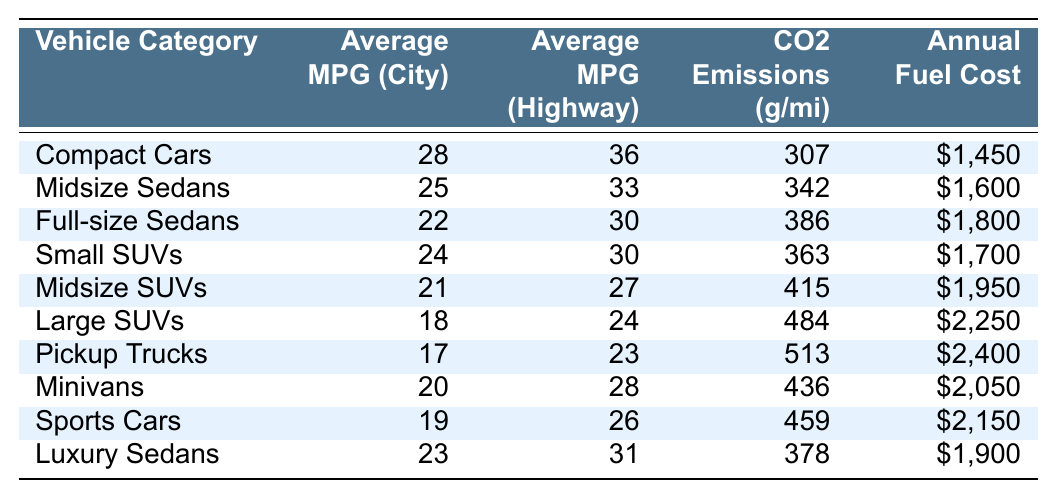What is the average MPG for Compact Cars in the city? From the table, the average MPG (City) for Compact Cars is directly listed as 28.
Answer: 28 What is the average highway MPG for Luxury Sedans? According to the table, the average MPG (Highway) for Luxury Sedans is provided as 31.
Answer: 31 Which vehicle category has the lowest CO2 emissions? The vehicle category with the lowest CO2 emissions, as per the table data, is Compact Cars with 307 g/mi.
Answer: Compact Cars What's the difference in annual fuel cost between Pickup Trucks and Small SUVs? According to the table, Pickup Trucks have an annual fuel cost of $2,400, and Small SUVs have $1,700. The difference is $2,400 - $1,700 = $700.
Answer: $700 Are Midsize SUVs more fuel-efficient in the city compared to Full-size Sedans? From the table, Midsize SUVs have an average MPG (City) of 21, while Full-size Sedans have 22. Thus, Midsize SUVs are not more fuel-efficient.
Answer: No What is the average CO2 emissions for both Sports Cars and Midsize Sedans? The CO2 emissions for Sports Cars is 459 g/mi and for Midsize Sedans is 342 g/mi. The average is (459 + 342) / 2 = 400.5 g/mi.
Answer: 400.5 Which vehicle category has the highest annual fuel cost? The table indicates that Pickup Trucks have the highest annual fuel cost at $2,400.
Answer: Pickup Trucks If you combine the average MPG for city driving of Compact Cars and Midsize SUVs, what do you get? Compact Cars average 28 MPG (City) and Midsize SUVs average 21 MPG (City). The combined total is 28 + 21 = 49 MPG.
Answer: 49 Do Large SUVs produce less CO2 emissions than Minivans? The CO2 emissions for Large SUVs is 484 g/mi and for Minivans is 436 g/mi. Since 484 is greater than 436, Large SUVs do not produce less CO2 emissions.
Answer: No What is the average annual fuel cost across all vehicle categories? The total annual fuel costs for each category are $1,450 + $1,600 + $1,800 + $1,700 + $1,950 + $2,250 + $2,400 + $2,050 + $2,150 + $1,900 = $20,250 for 10 categories. The average cost is $20,250 / 10 = $2,025.
Answer: $2,025 Which vehicle category has the best fuel efficiency on the highway? The table shows that Compact Cars have the highest average MPG (Highway) at 36.
Answer: Compact Cars 